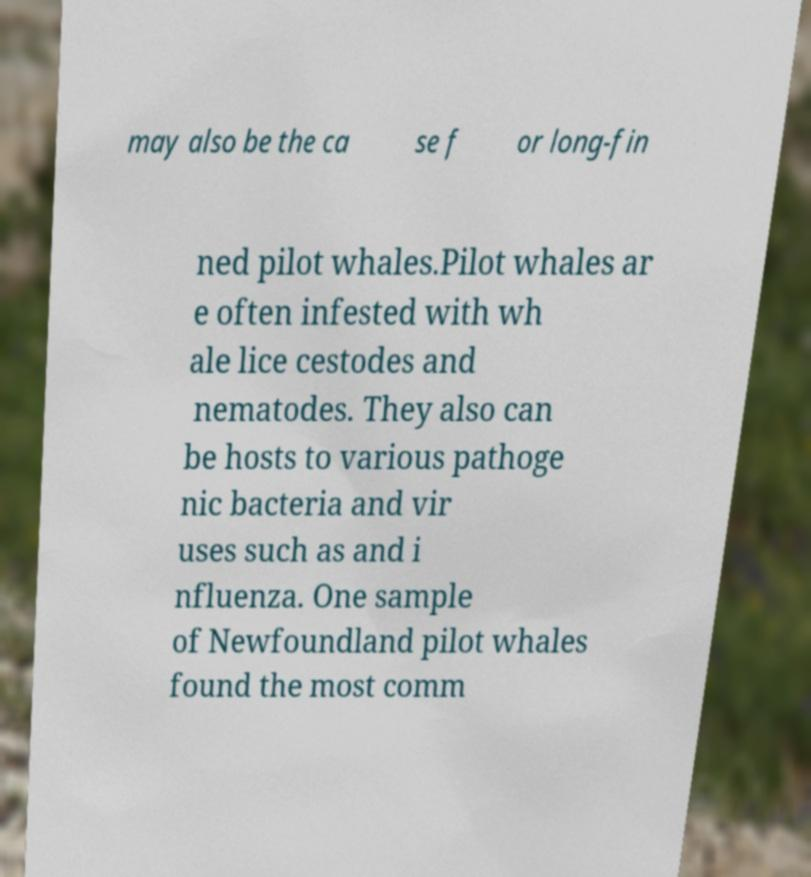For documentation purposes, I need the text within this image transcribed. Could you provide that? may also be the ca se f or long-fin ned pilot whales.Pilot whales ar e often infested with wh ale lice cestodes and nematodes. They also can be hosts to various pathoge nic bacteria and vir uses such as and i nfluenza. One sample of Newfoundland pilot whales found the most comm 